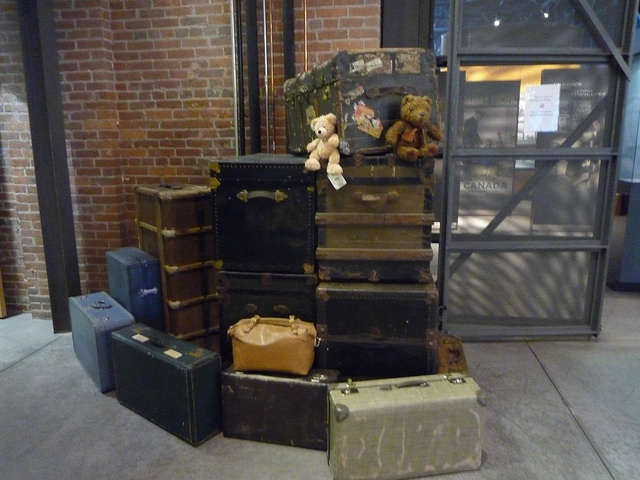Describe the objects in this image and their specific colors. I can see suitcase in black, gray, and tan tones, suitcase in black and gray tones, suitcase in black, gray, and olive tones, suitcase in black, gray, and darkgreen tones, and suitcase in black, gray, and purple tones in this image. 